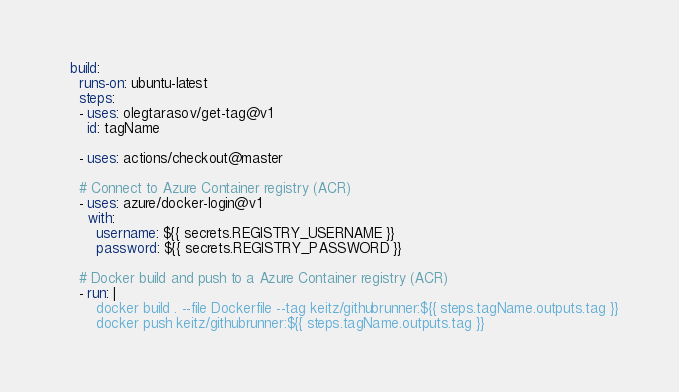Convert code to text. <code><loc_0><loc_0><loc_500><loc_500><_YAML_>
  build:
    runs-on: ubuntu-latest
    steps:
    - uses: olegtarasov/get-tag@v1
      id: tagName

    - uses: actions/checkout@master
    
    # Connect to Azure Container registry (ACR)
    - uses: azure/docker-login@v1
      with:
        username: ${{ secrets.REGISTRY_USERNAME }} 
        password: ${{ secrets.REGISTRY_PASSWORD }}
    
    # Docker build and push to a Azure Container registry (ACR)
    - run: |
        docker build . --file Dockerfile --tag keitz/githubrunner:${{ steps.tagName.outputs.tag }}
        docker push keitz/githubrunner:${{ steps.tagName.outputs.tag }}
</code> 